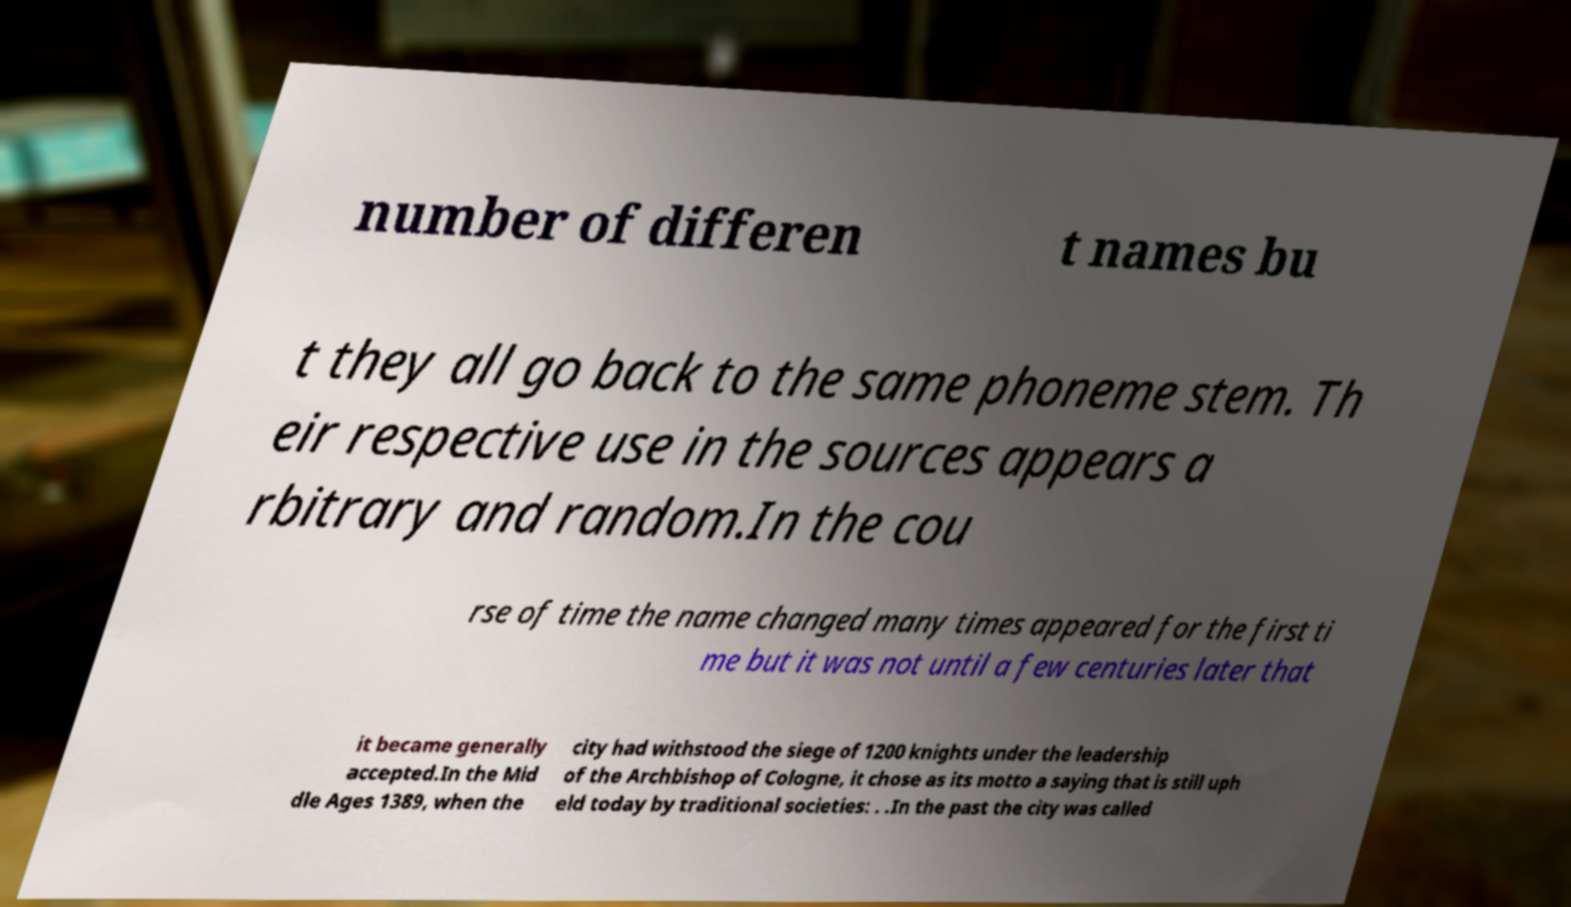Could you assist in decoding the text presented in this image and type it out clearly? number of differen t names bu t they all go back to the same phoneme stem. Th eir respective use in the sources appears a rbitrary and random.In the cou rse of time the name changed many times appeared for the first ti me but it was not until a few centuries later that it became generally accepted.In the Mid dle Ages 1389, when the city had withstood the siege of 1200 knights under the leadership of the Archbishop of Cologne, it chose as its motto a saying that is still uph eld today by traditional societies: . .In the past the city was called 